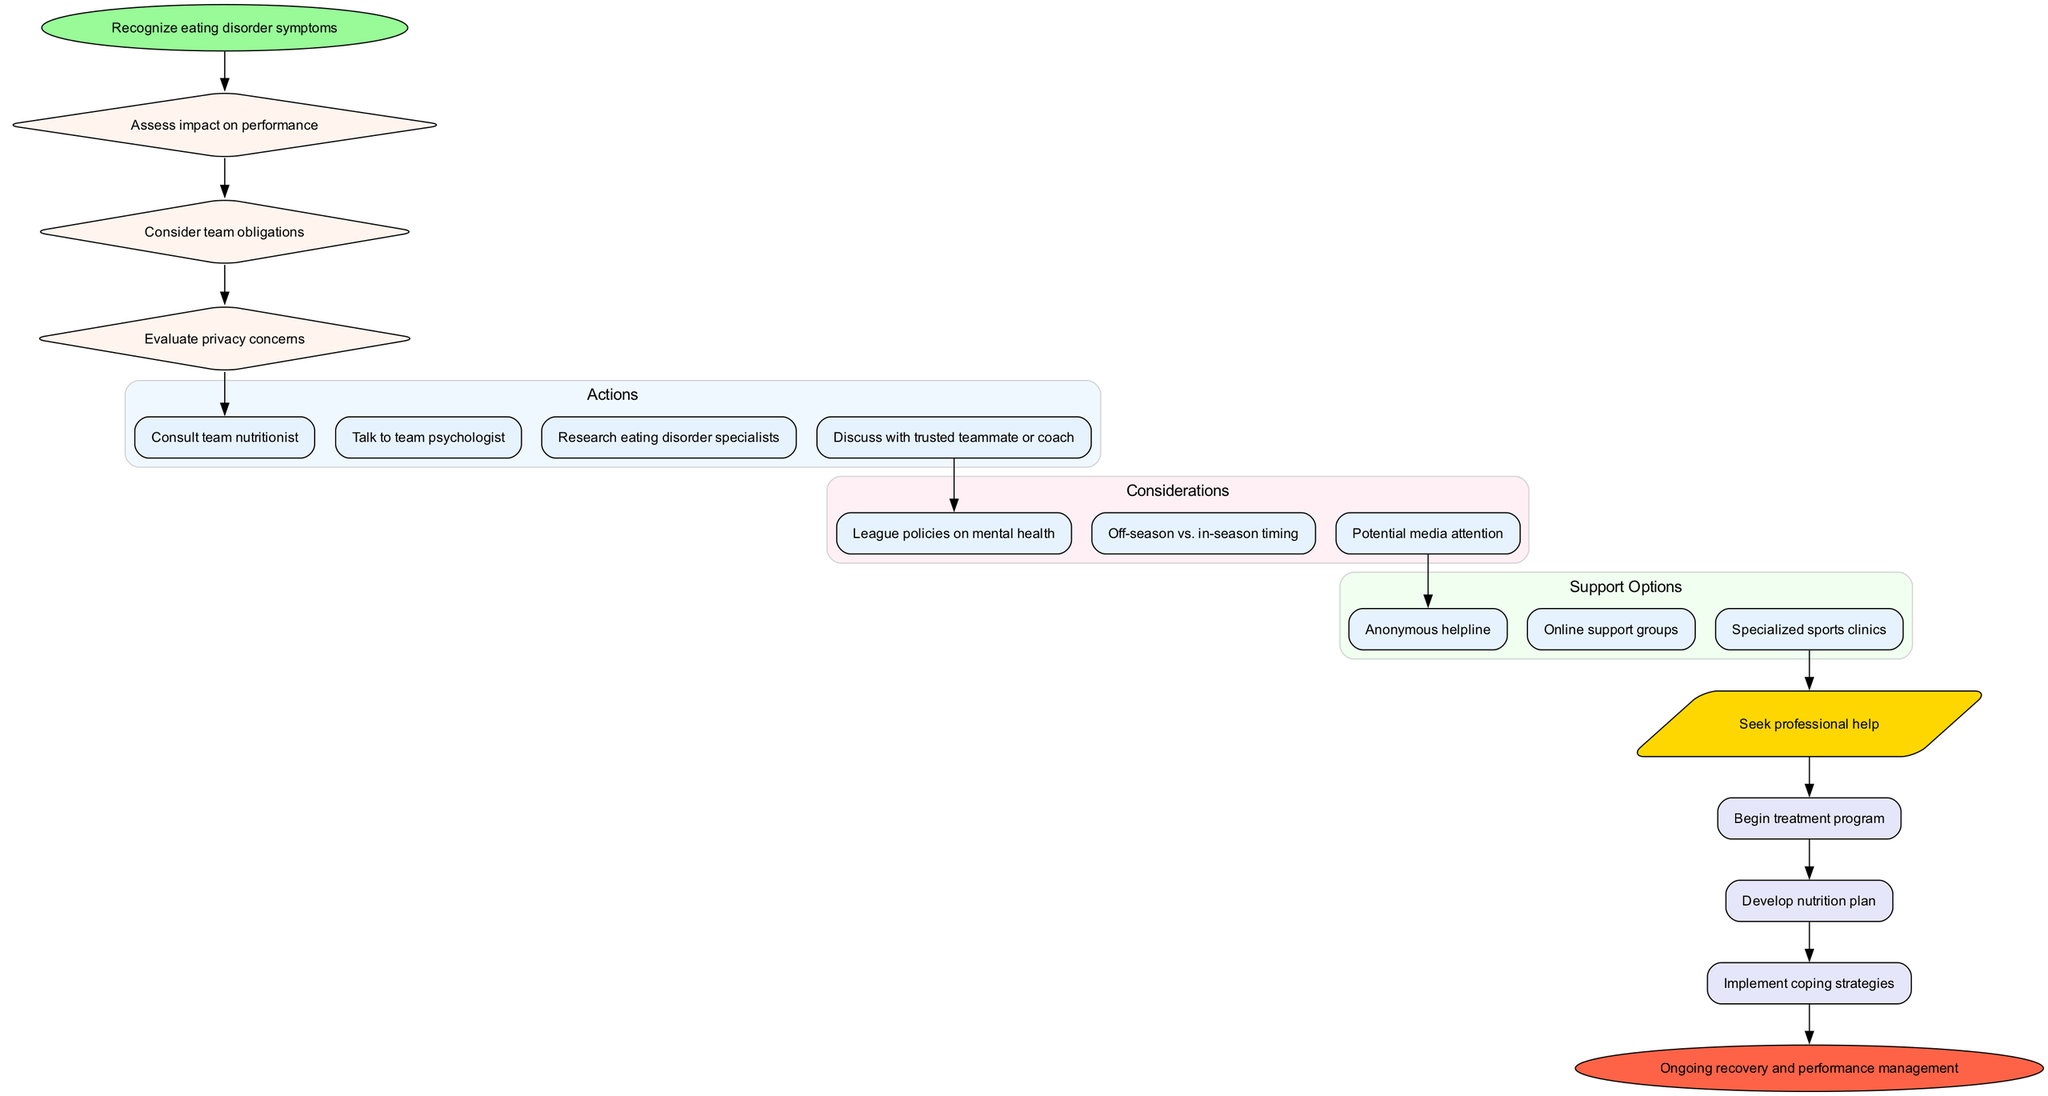What is the starting point of the diagram? The starting point of the diagram is labeled 'Recognize eating disorder symptoms'. This can be identified as the first node in the flow chart, which is positioned at the top and marked differently than other nodes.
Answer: Recognize eating disorder symptoms How many decision points are illustrated in the diagram? The diagram contains three decision points, which are labeled within diamond-shaped nodes. These nodes are connected in a sequence.
Answer: 3 What follows after discussing considerations? After discussing considerations, the next step in the diagram is to evaluate support options, which are shown in a cluster and represent various resources available.
Answer: Support Options Which action comes first after the last decision point? The first action after the last decision point is 'Consult team nutritionist', which directly connects to the final decision-making pathway related to seeking professional help.
Answer: Consult team nutritionist What is the final outcome depicted in the diagram? The last outcome shown in the diagram is 'Implement coping strategies', which is at the end of the outcomes section and signifies a step in the recovery process.
Answer: Implement coping strategies How does the decision point 'Consider team obligations' connect to the rest of the diagram? 'Consider team obligations' is one of the decision points and connects to the subsequent actions, reflecting the relationships in decision-making regarding performance and responsibilities.
Answer: It connects to actions Which support option is included in the diagram? The diagram includes 'Anonymous helpline' as one of the support options that athletes can reach out to for help. This is displayed in a distinct cluster that highlights available support resources.
Answer: Anonymous helpline What is indicated as the end of the diagram? The end of the diagram is indicated by the node labeled 'Ongoing recovery and performance management', marking the conclusion of the decision-making process for seeking help.
Answer: Ongoing recovery and performance management 